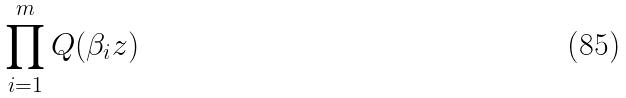Convert formula to latex. <formula><loc_0><loc_0><loc_500><loc_500>\prod _ { i = 1 } ^ { m } Q ( \beta _ { i } z )</formula> 